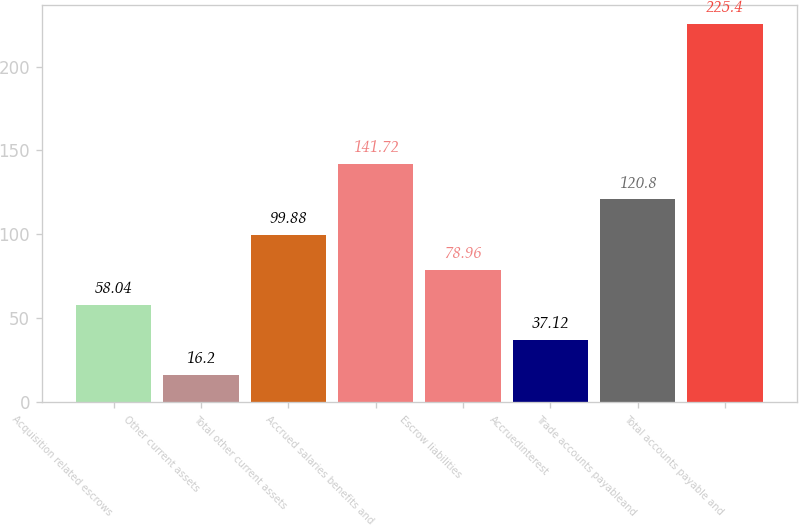Convert chart. <chart><loc_0><loc_0><loc_500><loc_500><bar_chart><fcel>Acquisition related escrows<fcel>Other current assets<fcel>Total other current assets<fcel>Accrued salaries benefits and<fcel>Escrow liabilities<fcel>Accruedinterest<fcel>Trade accounts payableand<fcel>Total accounts payable and<nl><fcel>58.04<fcel>16.2<fcel>99.88<fcel>141.72<fcel>78.96<fcel>37.12<fcel>120.8<fcel>225.4<nl></chart> 